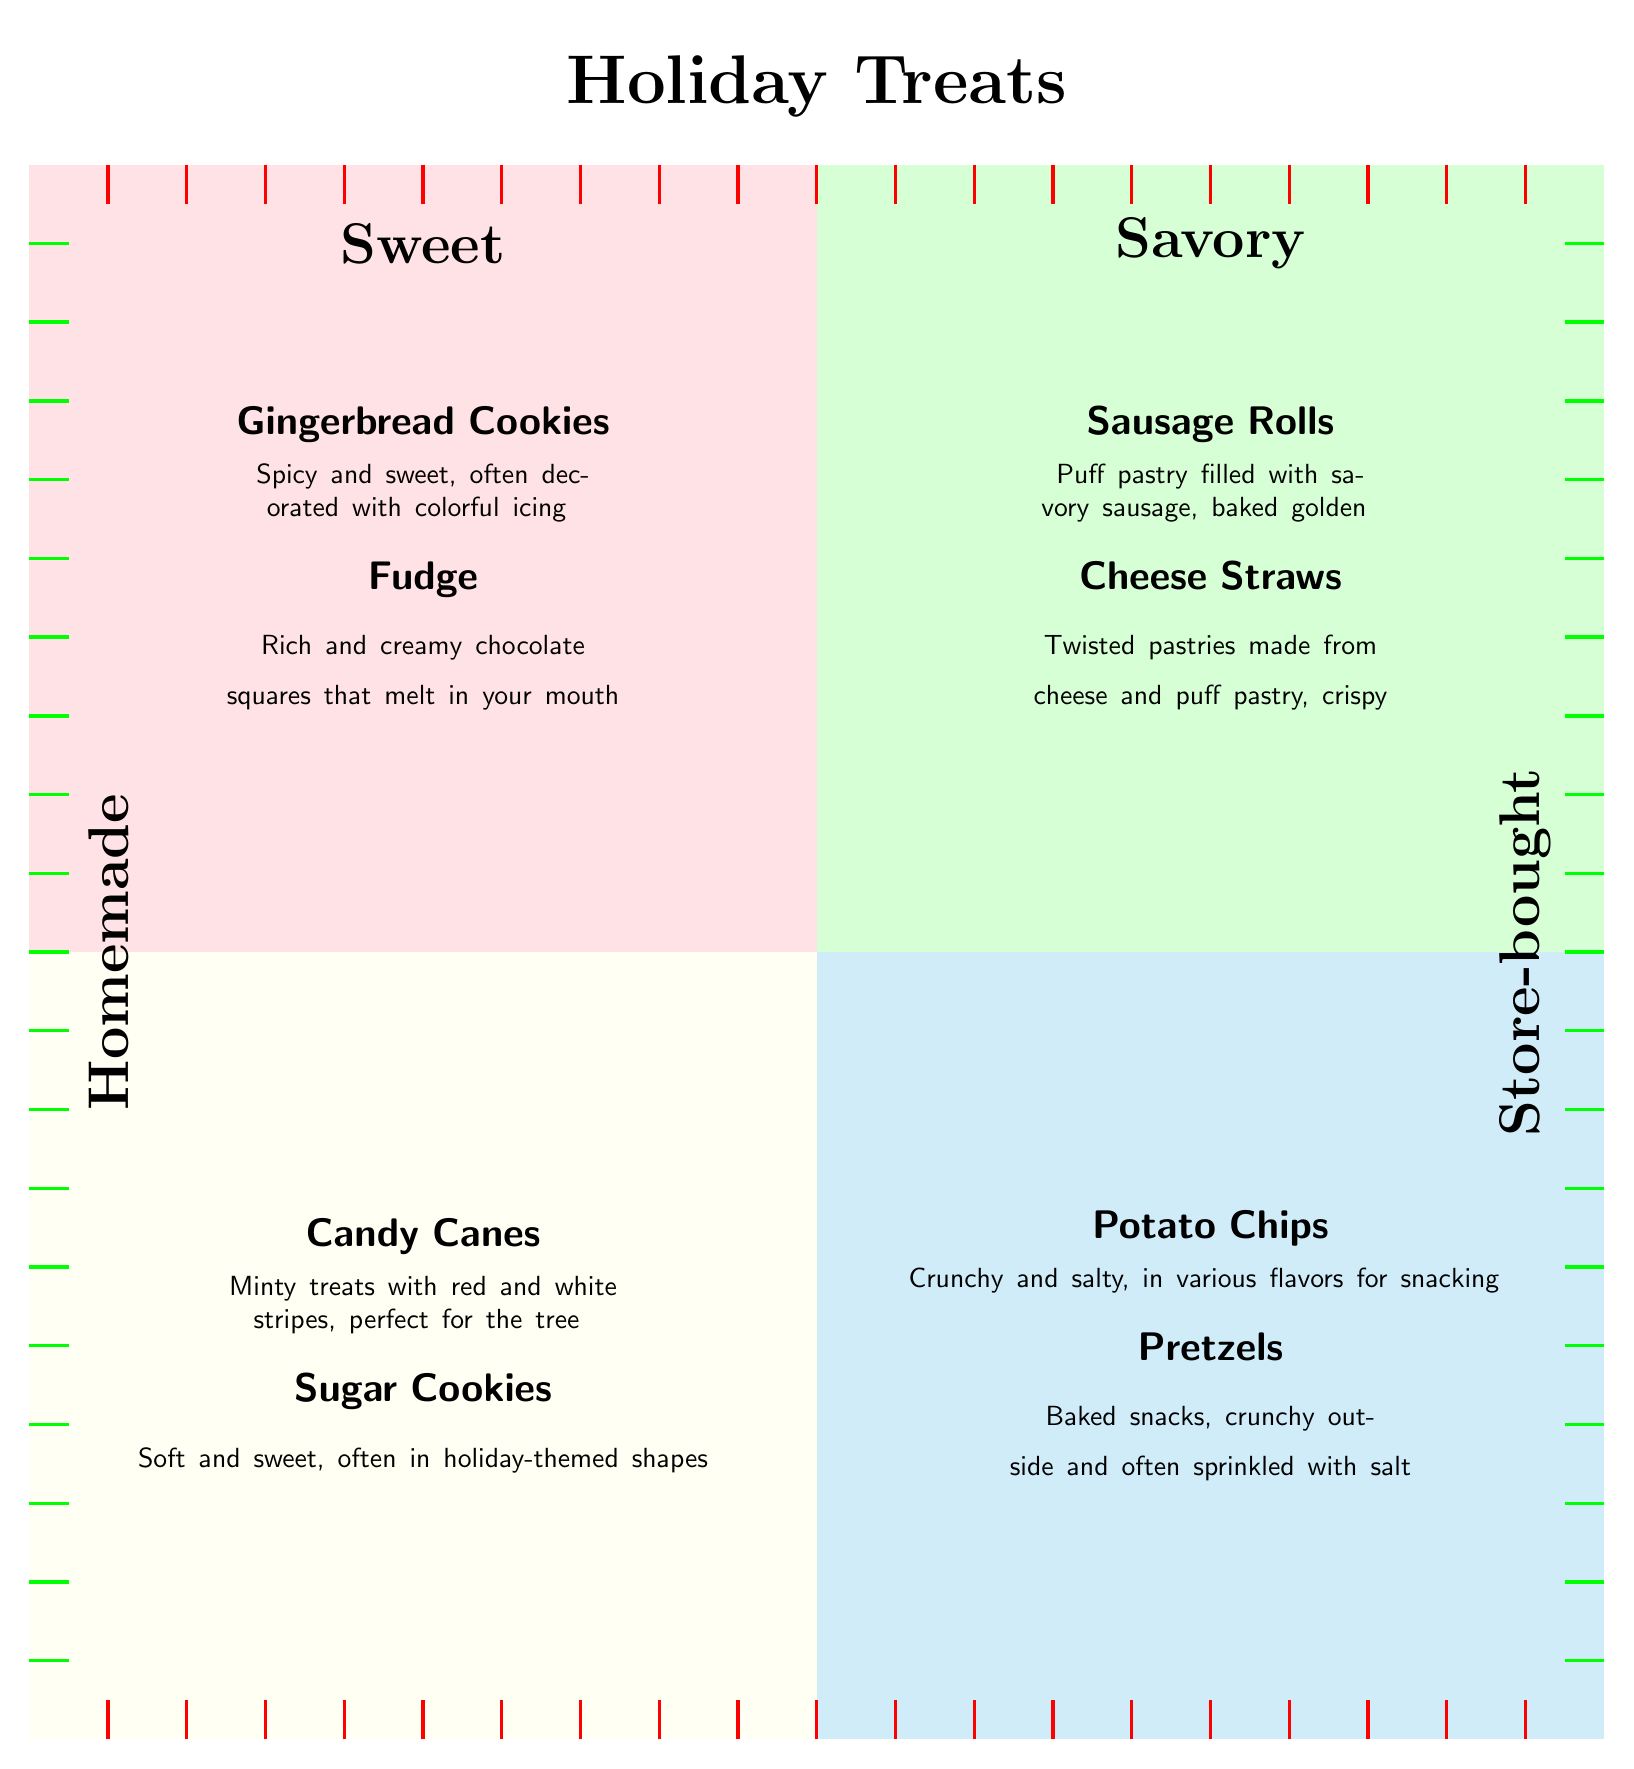What treats are displayed in the Sweet Homemade quadrant? The Sweet Homemade quadrant contains two treats: Gingerbread Cookies and Fudge. These are clearly labeled in the diagram with their descriptions directly below the titles.
Answer: Gingerbread Cookies, Fudge How many treats are in the Savory Store-bought quadrant? In the Savory Store-bought quadrant, there are two treats mentioned: Potato Chips and Pretzels. The count is obtained by simply observing how many items are listed in that section.
Answer: 2 Which category has the Gingerbread Cookies? The Gingerbread Cookies are located in the Sweet Homemade quadrant. This is determined by identifying the position of the treat in the diagram and its corresponding category label at the top left.
Answer: Sweet Homemade What is the description of Store-bought Sugar Cookies? The description of Store-bought Sugar Cookies is "Pre-made cookies that are soft and sweet, often sold with holiday-themed shapes." This is found directly beneath the treat's title in the diagram.
Answer: Pre-made cookies that are soft and sweet, often sold with holiday-themed shapes Which quadrant contains savory Homemade treats? The quadrant that contains savory Homemade treats is the one in the top right, labeled Savory and Homemade. By analyzing the diagram, you can determine this quadrant's position and its corresponding label.
Answer: Savory Homemade Are there any homemade sweet treats that contain chocolate? Yes, the Fudge is a homemade treat that contains chocolate. This conclusion is drawn from the description provided with the Fudge in the Sweet Homemade section.
Answer: Fudge What type of treats is mentioned at the bottom right quadrant? The bottom right quadrant contains Store-bought savory treats. This is confirmed by looking at the labels at the top and left of the quadrant and identifying the treats listed there.
Answer: Store-bought Savory Which treat is described as "Crispy and delicious"? The Cheese Straws are described as "Crispy and delicious". This description directly follows the name in the Savory Homemade section.
Answer: Cheese Straws 